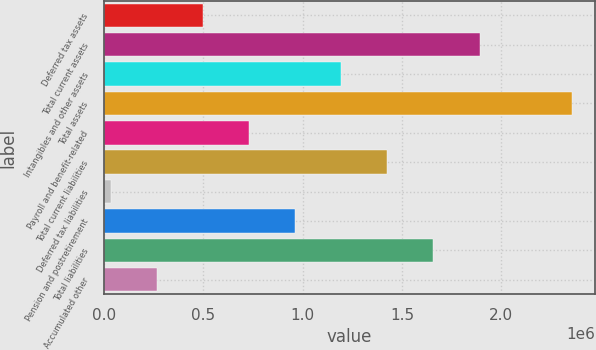Convert chart to OTSL. <chart><loc_0><loc_0><loc_500><loc_500><bar_chart><fcel>Deferred tax assets<fcel>Total current assets<fcel>Intangibles and other assets<fcel>Total assets<fcel>Payroll and benefit-related<fcel>Total current liabilities<fcel>Deferred tax liabilities<fcel>Pension and postretirement<fcel>Total liabilities<fcel>Accumulated other<nl><fcel>498565<fcel>1.88994e+06<fcel>1.19425e+06<fcel>2.35373e+06<fcel>730461<fcel>1.42615e+06<fcel>34774<fcel>962356<fcel>1.65804e+06<fcel>266670<nl></chart> 